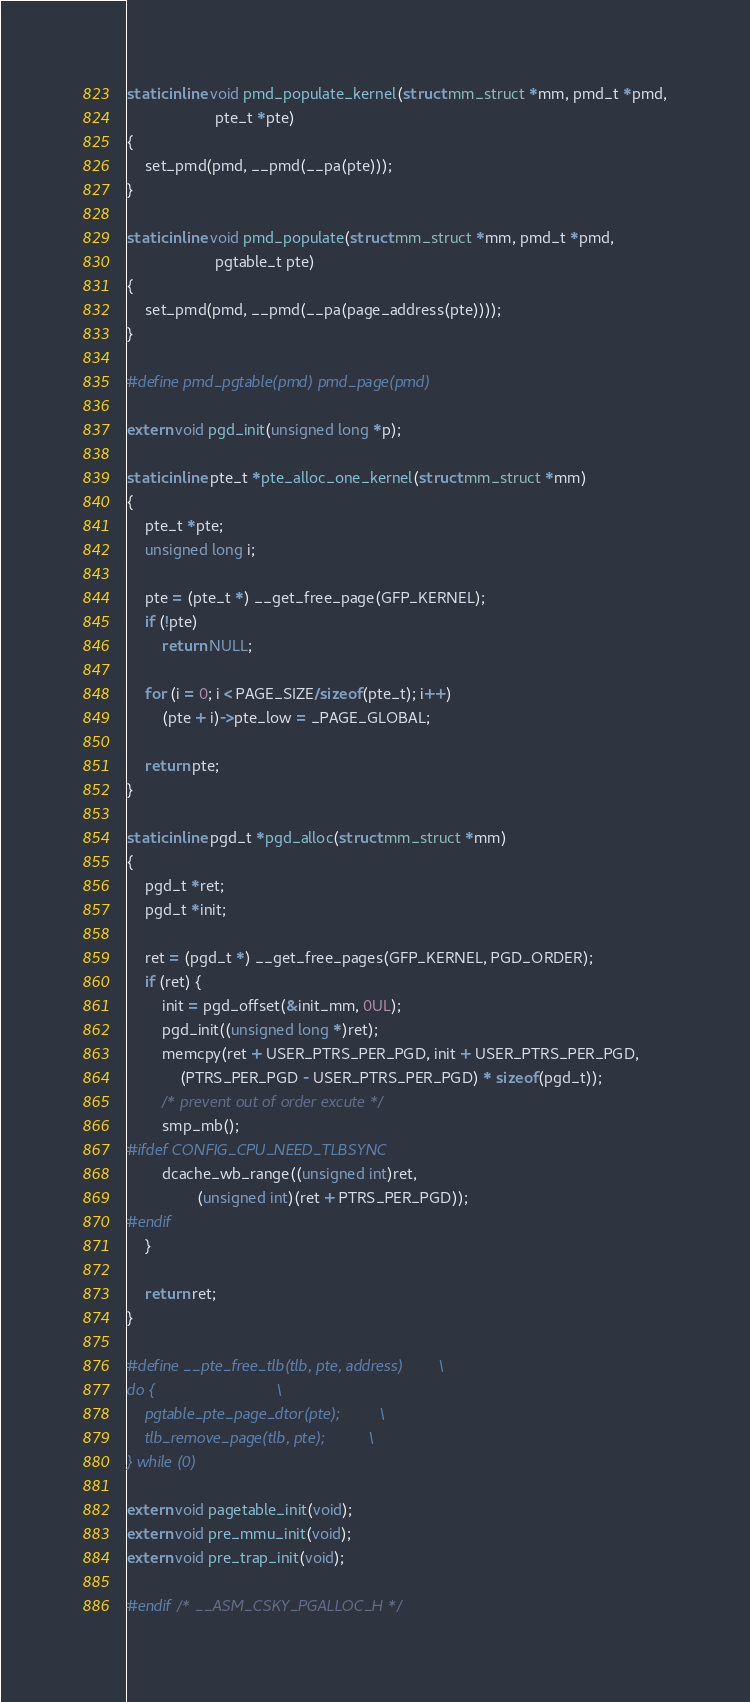Convert code to text. <code><loc_0><loc_0><loc_500><loc_500><_C_>static inline void pmd_populate_kernel(struct mm_struct *mm, pmd_t *pmd,
					pte_t *pte)
{
	set_pmd(pmd, __pmd(__pa(pte)));
}

static inline void pmd_populate(struct mm_struct *mm, pmd_t *pmd,
					pgtable_t pte)
{
	set_pmd(pmd, __pmd(__pa(page_address(pte))));
}

#define pmd_pgtable(pmd) pmd_page(pmd)

extern void pgd_init(unsigned long *p);

static inline pte_t *pte_alloc_one_kernel(struct mm_struct *mm)
{
	pte_t *pte;
	unsigned long i;

	pte = (pte_t *) __get_free_page(GFP_KERNEL);
	if (!pte)
		return NULL;

	for (i = 0; i < PAGE_SIZE/sizeof(pte_t); i++)
		(pte + i)->pte_low = _PAGE_GLOBAL;

	return pte;
}

static inline pgd_t *pgd_alloc(struct mm_struct *mm)
{
	pgd_t *ret;
	pgd_t *init;

	ret = (pgd_t *) __get_free_pages(GFP_KERNEL, PGD_ORDER);
	if (ret) {
		init = pgd_offset(&init_mm, 0UL);
		pgd_init((unsigned long *)ret);
		memcpy(ret + USER_PTRS_PER_PGD, init + USER_PTRS_PER_PGD,
			(PTRS_PER_PGD - USER_PTRS_PER_PGD) * sizeof(pgd_t));
		/* prevent out of order excute */
		smp_mb();
#ifdef CONFIG_CPU_NEED_TLBSYNC
		dcache_wb_range((unsigned int)ret,
				(unsigned int)(ret + PTRS_PER_PGD));
#endif
	}

	return ret;
}

#define __pte_free_tlb(tlb, pte, address)		\
do {							\
	pgtable_pte_page_dtor(pte);			\
	tlb_remove_page(tlb, pte);			\
} while (0)

extern void pagetable_init(void);
extern void pre_mmu_init(void);
extern void pre_trap_init(void);

#endif /* __ASM_CSKY_PGALLOC_H */
</code> 